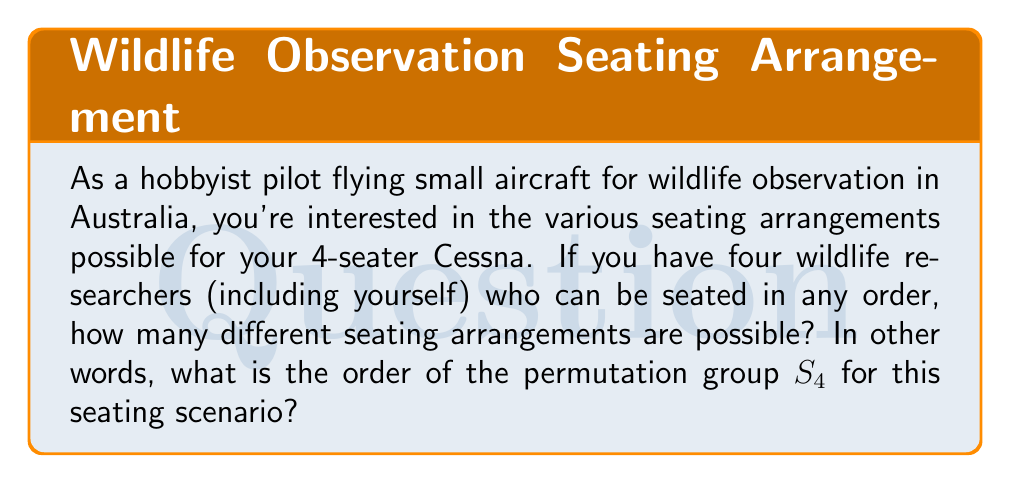Teach me how to tackle this problem. To solve this problem, we need to understand the concept of permutation groups and how to calculate their order.

1) In this case, we are dealing with the symmetric group $S_4$, which represents all possible permutations of 4 distinct objects (in this case, the 4 seats in the Cessna).

2) The order of a permutation group is equal to the number of distinct permutations possible. For $n$ distinct objects, this is given by $n!$ (n factorial).

3) In our case, $n = 4$, so we need to calculate $4!$:

   $$4! = 4 \times 3 \times 2 \times 1 = 24$$

4) We can break this down further to understand why:
   - The first person (pilot) has 4 choices for their seat
   - The second person then has 3 remaining choices
   - The third person has 2 choices left
   - The last person must take the remaining seat

5) Multiplying these choices together gives us the total number of possible arrangements:

   $$4 \times 3 \times 2 \times 1 = 24$$

Therefore, the order of the permutation group $S_4$ for this seating scenario is 24.
Answer: The order of the permutation group $S_4$ for the 4-seater aircraft seating arrangements is 24. 